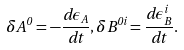Convert formula to latex. <formula><loc_0><loc_0><loc_500><loc_500>\delta A ^ { 0 } = - \frac { d \epsilon _ { A } } { d t } , \delta B ^ { 0 i } = \frac { d \epsilon ^ { i } _ { B } } { d t } .</formula> 